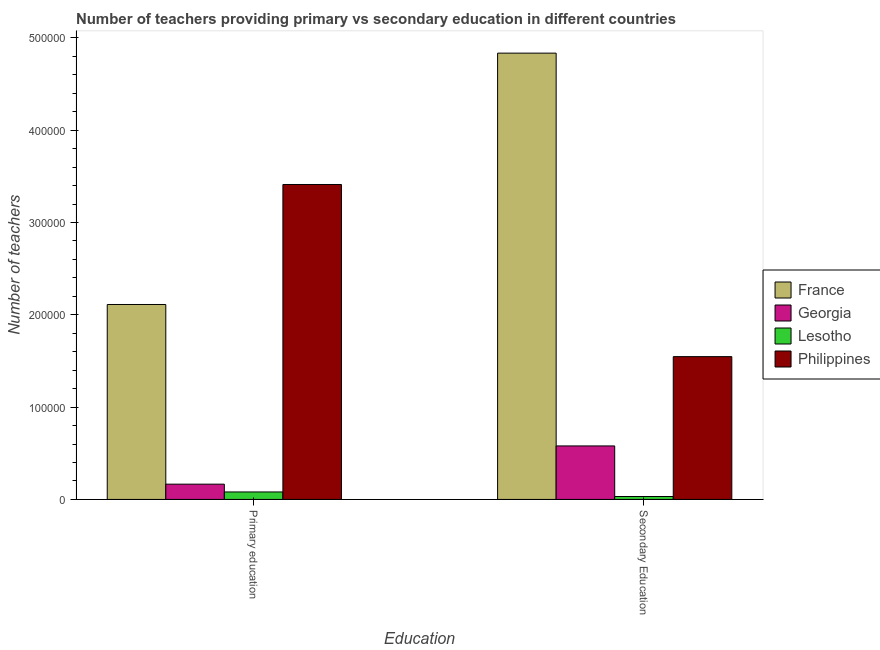How many different coloured bars are there?
Your answer should be very brief. 4. Are the number of bars on each tick of the X-axis equal?
Ensure brevity in your answer.  Yes. How many bars are there on the 2nd tick from the right?
Ensure brevity in your answer.  4. What is the label of the 2nd group of bars from the left?
Your answer should be very brief. Secondary Education. What is the number of primary teachers in France?
Your answer should be compact. 2.11e+05. Across all countries, what is the maximum number of primary teachers?
Give a very brief answer. 3.41e+05. Across all countries, what is the minimum number of primary teachers?
Your answer should be compact. 8089. In which country was the number of primary teachers minimum?
Make the answer very short. Lesotho. What is the total number of primary teachers in the graph?
Keep it short and to the point. 5.77e+05. What is the difference between the number of secondary teachers in Philippines and that in France?
Keep it short and to the point. -3.29e+05. What is the difference between the number of primary teachers in Georgia and the number of secondary teachers in Philippines?
Your answer should be very brief. -1.38e+05. What is the average number of primary teachers per country?
Your response must be concise. 1.44e+05. What is the difference between the number of primary teachers and number of secondary teachers in Philippines?
Offer a very short reply. 1.86e+05. What is the ratio of the number of secondary teachers in Lesotho to that in Georgia?
Give a very brief answer. 0.05. Is the number of secondary teachers in France less than that in Philippines?
Your response must be concise. No. What does the 4th bar from the left in Secondary Education represents?
Your response must be concise. Philippines. What does the 3rd bar from the right in Primary education represents?
Offer a very short reply. Georgia. How many bars are there?
Give a very brief answer. 8. How many countries are there in the graph?
Your answer should be compact. 4. What is the difference between two consecutive major ticks on the Y-axis?
Your response must be concise. 1.00e+05. Are the values on the major ticks of Y-axis written in scientific E-notation?
Give a very brief answer. No. Does the graph contain grids?
Your answer should be compact. No. Where does the legend appear in the graph?
Your answer should be very brief. Center right. How are the legend labels stacked?
Your answer should be very brief. Vertical. What is the title of the graph?
Provide a succinct answer. Number of teachers providing primary vs secondary education in different countries. Does "Sierra Leone" appear as one of the legend labels in the graph?
Your answer should be compact. No. What is the label or title of the X-axis?
Provide a succinct answer. Education. What is the label or title of the Y-axis?
Keep it short and to the point. Number of teachers. What is the Number of teachers of France in Primary education?
Ensure brevity in your answer.  2.11e+05. What is the Number of teachers in Georgia in Primary education?
Keep it short and to the point. 1.65e+04. What is the Number of teachers of Lesotho in Primary education?
Give a very brief answer. 8089. What is the Number of teachers in Philippines in Primary education?
Offer a very short reply. 3.41e+05. What is the Number of teachers in France in Secondary Education?
Your response must be concise. 4.83e+05. What is the Number of teachers of Georgia in Secondary Education?
Offer a terse response. 5.80e+04. What is the Number of teachers of Lesotho in Secondary Education?
Offer a terse response. 3158. What is the Number of teachers in Philippines in Secondary Education?
Offer a very short reply. 1.55e+05. Across all Education, what is the maximum Number of teachers of France?
Ensure brevity in your answer.  4.83e+05. Across all Education, what is the maximum Number of teachers of Georgia?
Make the answer very short. 5.80e+04. Across all Education, what is the maximum Number of teachers in Lesotho?
Give a very brief answer. 8089. Across all Education, what is the maximum Number of teachers in Philippines?
Give a very brief answer. 3.41e+05. Across all Education, what is the minimum Number of teachers in France?
Offer a terse response. 2.11e+05. Across all Education, what is the minimum Number of teachers in Georgia?
Keep it short and to the point. 1.65e+04. Across all Education, what is the minimum Number of teachers of Lesotho?
Make the answer very short. 3158. Across all Education, what is the minimum Number of teachers in Philippines?
Keep it short and to the point. 1.55e+05. What is the total Number of teachers in France in the graph?
Ensure brevity in your answer.  6.95e+05. What is the total Number of teachers of Georgia in the graph?
Provide a short and direct response. 7.45e+04. What is the total Number of teachers in Lesotho in the graph?
Your answer should be very brief. 1.12e+04. What is the total Number of teachers in Philippines in the graph?
Offer a very short reply. 4.96e+05. What is the difference between the Number of teachers in France in Primary education and that in Secondary Education?
Your answer should be very brief. -2.72e+05. What is the difference between the Number of teachers of Georgia in Primary education and that in Secondary Education?
Your answer should be compact. -4.14e+04. What is the difference between the Number of teachers of Lesotho in Primary education and that in Secondary Education?
Give a very brief answer. 4931. What is the difference between the Number of teachers of Philippines in Primary education and that in Secondary Education?
Provide a succinct answer. 1.86e+05. What is the difference between the Number of teachers of France in Primary education and the Number of teachers of Georgia in Secondary Education?
Your answer should be compact. 1.53e+05. What is the difference between the Number of teachers in France in Primary education and the Number of teachers in Lesotho in Secondary Education?
Your response must be concise. 2.08e+05. What is the difference between the Number of teachers of France in Primary education and the Number of teachers of Philippines in Secondary Education?
Ensure brevity in your answer.  5.65e+04. What is the difference between the Number of teachers of Georgia in Primary education and the Number of teachers of Lesotho in Secondary Education?
Your answer should be compact. 1.34e+04. What is the difference between the Number of teachers of Georgia in Primary education and the Number of teachers of Philippines in Secondary Education?
Your answer should be compact. -1.38e+05. What is the difference between the Number of teachers in Lesotho in Primary education and the Number of teachers in Philippines in Secondary Education?
Offer a very short reply. -1.47e+05. What is the average Number of teachers in France per Education?
Your answer should be compact. 3.47e+05. What is the average Number of teachers in Georgia per Education?
Keep it short and to the point. 3.73e+04. What is the average Number of teachers of Lesotho per Education?
Your answer should be compact. 5623.5. What is the average Number of teachers of Philippines per Education?
Your answer should be very brief. 2.48e+05. What is the difference between the Number of teachers in France and Number of teachers in Georgia in Primary education?
Keep it short and to the point. 1.95e+05. What is the difference between the Number of teachers of France and Number of teachers of Lesotho in Primary education?
Offer a very short reply. 2.03e+05. What is the difference between the Number of teachers of France and Number of teachers of Philippines in Primary education?
Keep it short and to the point. -1.30e+05. What is the difference between the Number of teachers of Georgia and Number of teachers of Lesotho in Primary education?
Offer a terse response. 8453. What is the difference between the Number of teachers of Georgia and Number of teachers of Philippines in Primary education?
Make the answer very short. -3.25e+05. What is the difference between the Number of teachers of Lesotho and Number of teachers of Philippines in Primary education?
Offer a very short reply. -3.33e+05. What is the difference between the Number of teachers in France and Number of teachers in Georgia in Secondary Education?
Provide a short and direct response. 4.26e+05. What is the difference between the Number of teachers in France and Number of teachers in Lesotho in Secondary Education?
Provide a short and direct response. 4.80e+05. What is the difference between the Number of teachers of France and Number of teachers of Philippines in Secondary Education?
Keep it short and to the point. 3.29e+05. What is the difference between the Number of teachers in Georgia and Number of teachers in Lesotho in Secondary Education?
Your answer should be compact. 5.48e+04. What is the difference between the Number of teachers of Georgia and Number of teachers of Philippines in Secondary Education?
Your answer should be very brief. -9.67e+04. What is the difference between the Number of teachers of Lesotho and Number of teachers of Philippines in Secondary Education?
Offer a terse response. -1.52e+05. What is the ratio of the Number of teachers of France in Primary education to that in Secondary Education?
Your answer should be compact. 0.44. What is the ratio of the Number of teachers of Georgia in Primary education to that in Secondary Education?
Your answer should be very brief. 0.29. What is the ratio of the Number of teachers in Lesotho in Primary education to that in Secondary Education?
Your answer should be very brief. 2.56. What is the ratio of the Number of teachers of Philippines in Primary education to that in Secondary Education?
Offer a terse response. 2.21. What is the difference between the highest and the second highest Number of teachers in France?
Give a very brief answer. 2.72e+05. What is the difference between the highest and the second highest Number of teachers of Georgia?
Make the answer very short. 4.14e+04. What is the difference between the highest and the second highest Number of teachers of Lesotho?
Provide a short and direct response. 4931. What is the difference between the highest and the second highest Number of teachers in Philippines?
Your answer should be very brief. 1.86e+05. What is the difference between the highest and the lowest Number of teachers of France?
Provide a short and direct response. 2.72e+05. What is the difference between the highest and the lowest Number of teachers of Georgia?
Provide a succinct answer. 4.14e+04. What is the difference between the highest and the lowest Number of teachers in Lesotho?
Your response must be concise. 4931. What is the difference between the highest and the lowest Number of teachers in Philippines?
Your answer should be compact. 1.86e+05. 